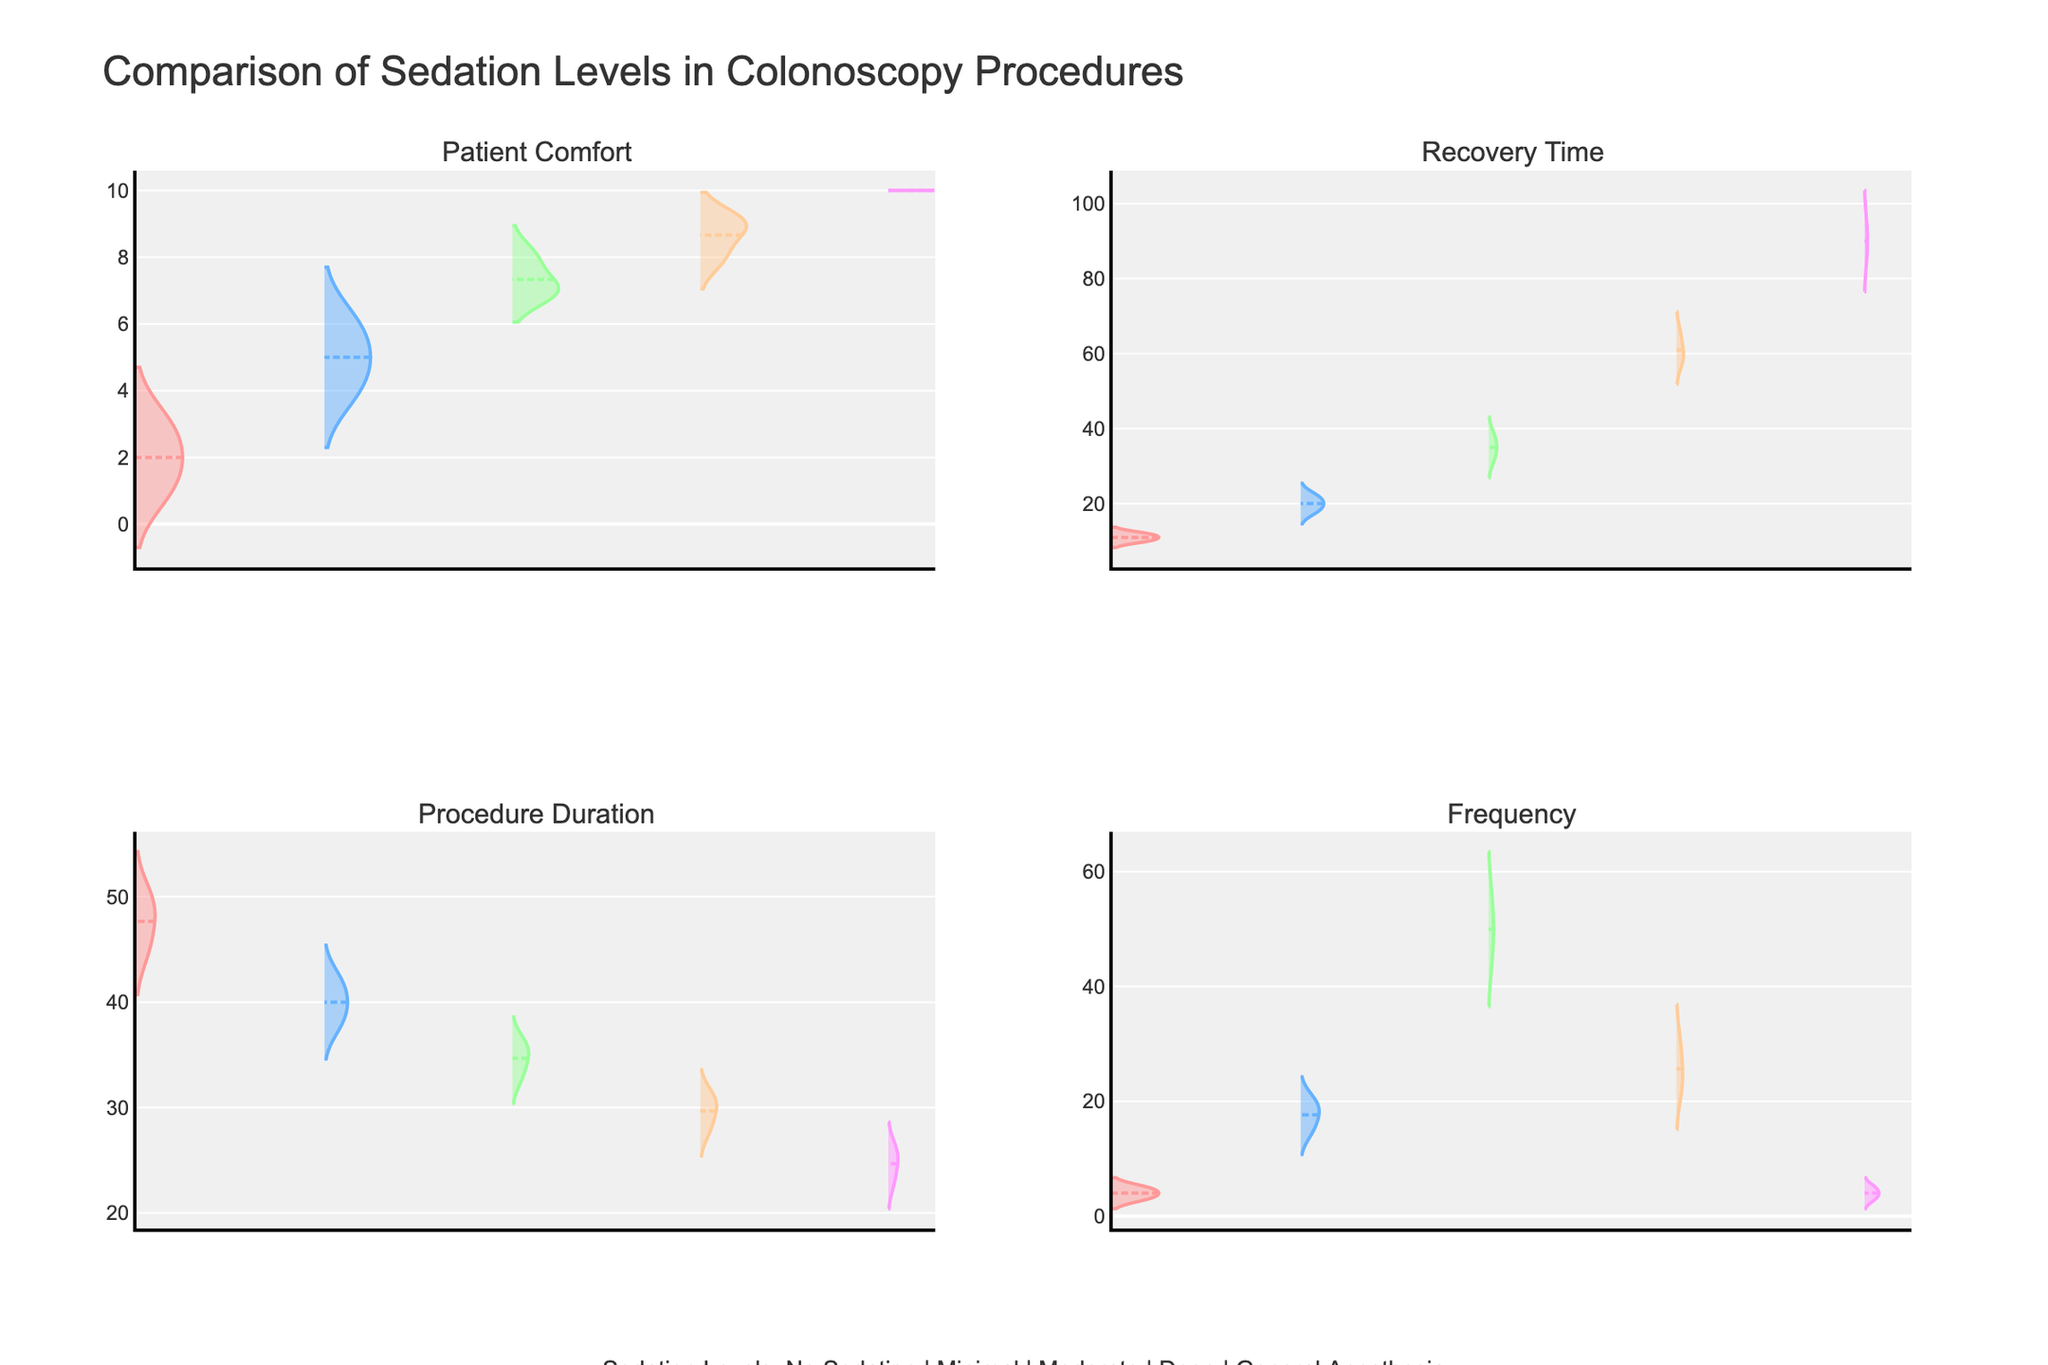Which sedation level shows the highest patient comfort? The highest patient comfort can be identified by looking for the sedation level with the highest peak in the "Patient Comfort" subplot. From this plot, General Anesthesia has the highest patient comfort with values consistently around 10.
Answer: General Anesthesia Which sedation level generally results in the shortest recovery time? By examining the "Recovery Time" subplot, the sedation level with the lowest range of values represents the shortest recovery time. General Anesthesia shows consistently low recovery times, peaking around 25 to 30 minutes.
Answer: General Anesthesia How do the procedure durations compare between Moderate Sedation and Deep Sedation? In the "Procedure Duration" subplot, the procedure durations for Moderate Sedation appear to be centered around 33 to 36 minutes, whereas Deep Sedation is centered lower around 28 to 31 minutes.
Answer: Deep Sedation is shorter What is the trend in frequency across the different sedation levels? Referencing the "Frequency" subplot, the sedation levels with the highest frequency are Moderate Sedation and Deep Sedation. No Sedation and General Anesthesia have the lowest frequencies.
Answer: Moderate and Deep Sedation are the highest How does the recovery time for Minimal Sedation compare to Moderate Sedation? In the "Recovery Time" subplot, Minimal Sedation has recovery times generally lower, peaking around 18 to 22 minutes compared to Moderate Sedation which peaks around 35 to 38 minutes.
Answer: Minimal Sedation is shorter Which sedation level has the widest range of recovery times? By examining the spread of data in the "Recovery Time" subplot, Deep Sedation and General Anesthesia show the widest ranges, with recovery times spanning from approximately 58 to 65 minutes and 85 to 95 minutes respectively.
Answer: Deep Sedation and General Anesthesia Is there a significant difference in patient comfort between Minimal Sedation and Moderate Sedation? In the "Patient Comfort" subplot, Moderate Sedation has a higher overall range (around 7 to 8) compared to Minimal Sedation (around 4 to 6). This indicates a higher patient comfort for Moderate Sedation.
Answer: Yes, Moderate Sedation is higher Which sedation level results in the longest procedure duration on average? From the "Procedure Duration" subplot, No Sedation has the highest average procedure duration, around 45 to 50 minutes.
Answer: No Sedation How does General Anesthesia affect patient comfort compared to all other sedation levels? General Anesthesia in the "Patient Comfort" subplot shows the highest comfort level consistently near 10, indicating it provides the highest patient comfort compared to others.
Answer: General Anesthesia is highest How are mean lines depicted in the figure for each sedation level? The mean lines for each sedation level in all subplots are indicated by a visible horizontal line within each density plot, showing the average value for that variable.
Answer: Horizontal lines within density plots 